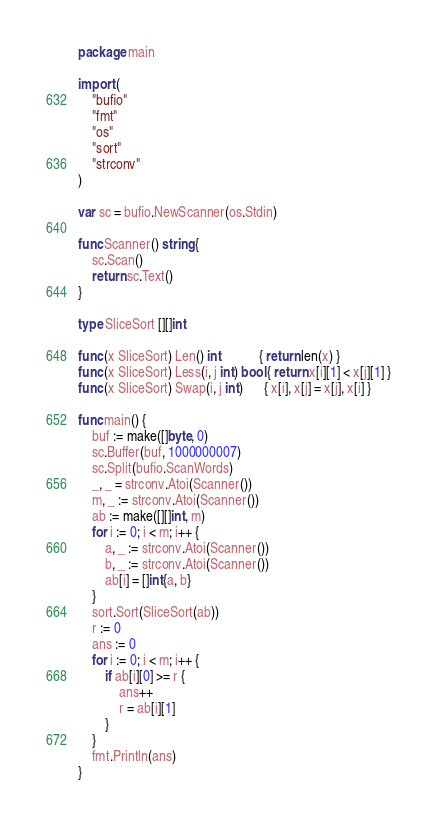Convert code to text. <code><loc_0><loc_0><loc_500><loc_500><_Go_>package main

import (
	"bufio"
	"fmt"
	"os"
	"sort"
	"strconv"
)

var sc = bufio.NewScanner(os.Stdin)

func Scanner() string {
	sc.Scan()
	return sc.Text()
}

type SliceSort [][]int

func (x SliceSort) Len() int           { return len(x) }
func (x SliceSort) Less(i, j int) bool { return x[i][1] < x[j][1] }
func (x SliceSort) Swap(i, j int)      { x[i], x[j] = x[j], x[i] }

func main() {
	buf := make([]byte, 0)
	sc.Buffer(buf, 1000000007)
	sc.Split(bufio.ScanWords)
	_, _ = strconv.Atoi(Scanner())
	m, _ := strconv.Atoi(Scanner())
	ab := make([][]int, m)
	for i := 0; i < m; i++ {
		a, _ := strconv.Atoi(Scanner())
		b, _ := strconv.Atoi(Scanner())
		ab[i] = []int{a, b}
	}
	sort.Sort(SliceSort(ab))
	r := 0
	ans := 0
	for i := 0; i < m; i++ {
		if ab[i][0] >= r {
			ans++
			r = ab[i][1]
		}
	}
	fmt.Println(ans)
}
</code> 